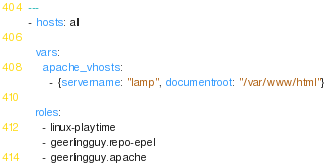<code> <loc_0><loc_0><loc_500><loc_500><_YAML_>---
- hosts: all

  vars:
    apache_vhosts:
      - {servername: "lamp", documentroot: "/var/www/html"}

  roles:
    - linux-playtime
    - geerlingguy.repo-epel
    - geerlingguy.apache
</code> 